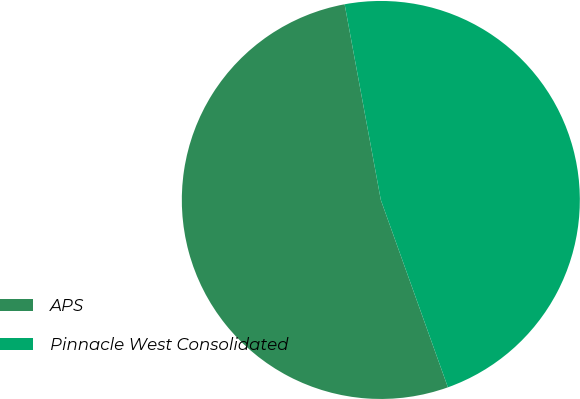Convert chart. <chart><loc_0><loc_0><loc_500><loc_500><pie_chart><fcel>APS<fcel>Pinnacle West Consolidated<nl><fcel>52.56%<fcel>47.44%<nl></chart> 